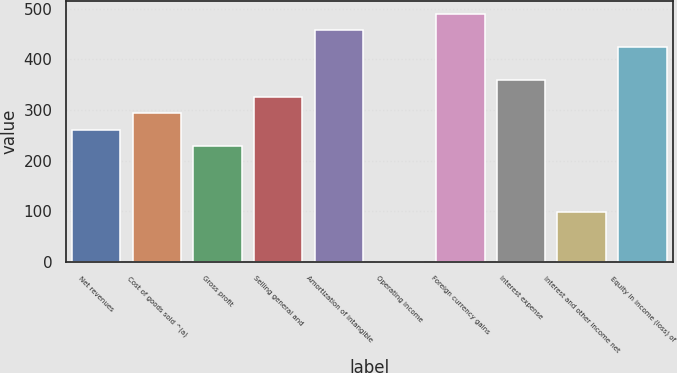Convert chart to OTSL. <chart><loc_0><loc_0><loc_500><loc_500><bar_chart><fcel>Net revenues<fcel>Cost of goods sold ^(a)<fcel>Gross profit<fcel>Selling general and<fcel>Amortization of intangible<fcel>Operating income<fcel>Foreign currency gains<fcel>Interest expense<fcel>Interest and other income net<fcel>Equity in income (loss) of<nl><fcel>261.38<fcel>294.04<fcel>228.72<fcel>326.7<fcel>457.34<fcel>0.1<fcel>490<fcel>359.36<fcel>98.08<fcel>424.68<nl></chart> 